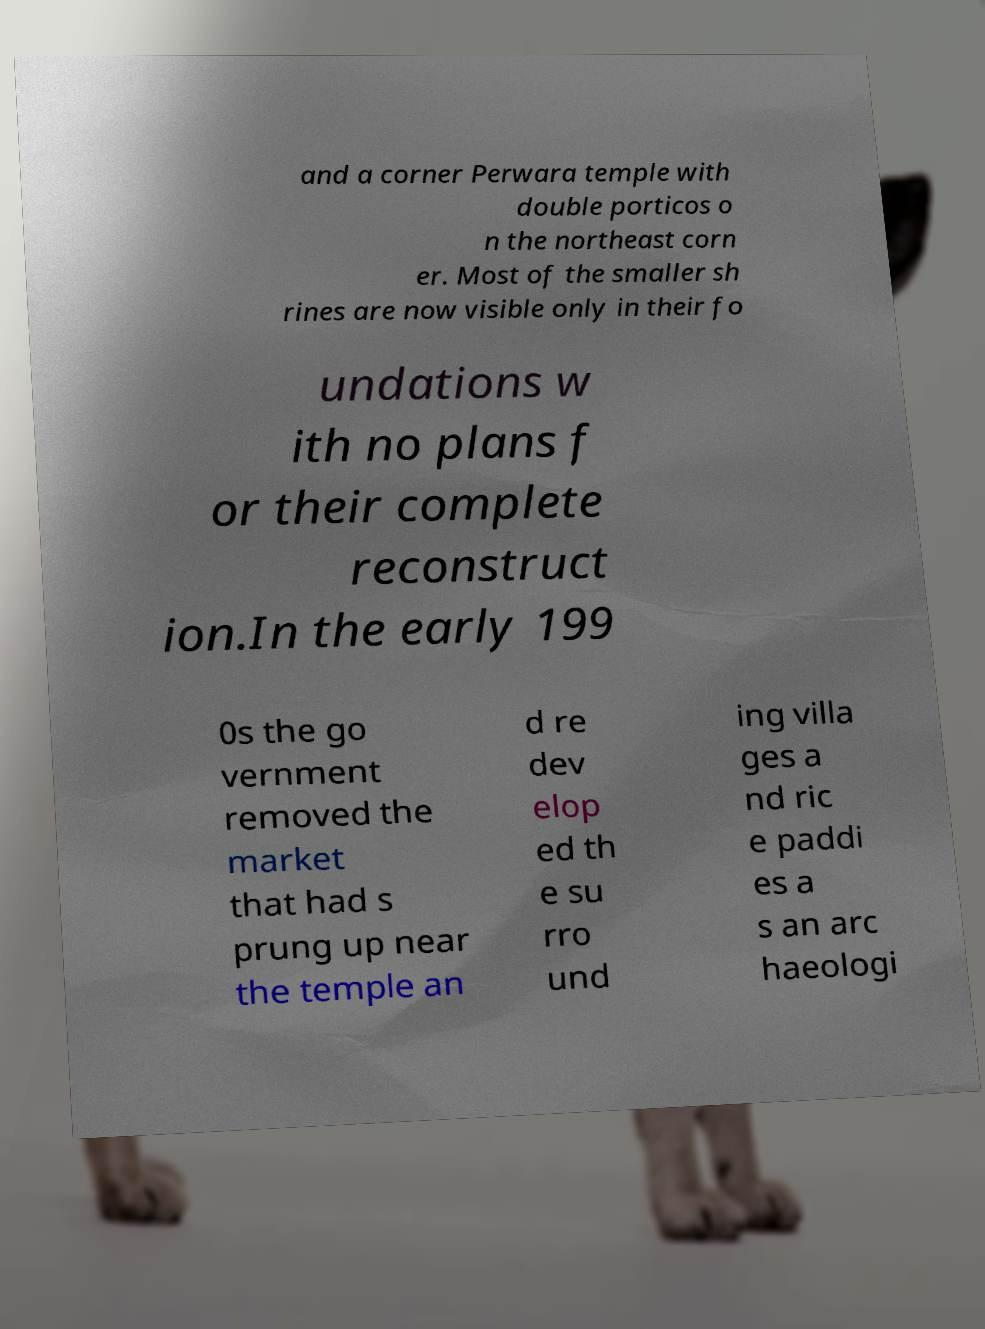Please read and relay the text visible in this image. What does it say? and a corner Perwara temple with double porticos o n the northeast corn er. Most of the smaller sh rines are now visible only in their fo undations w ith no plans f or their complete reconstruct ion.In the early 199 0s the go vernment removed the market that had s prung up near the temple an d re dev elop ed th e su rro und ing villa ges a nd ric e paddi es a s an arc haeologi 